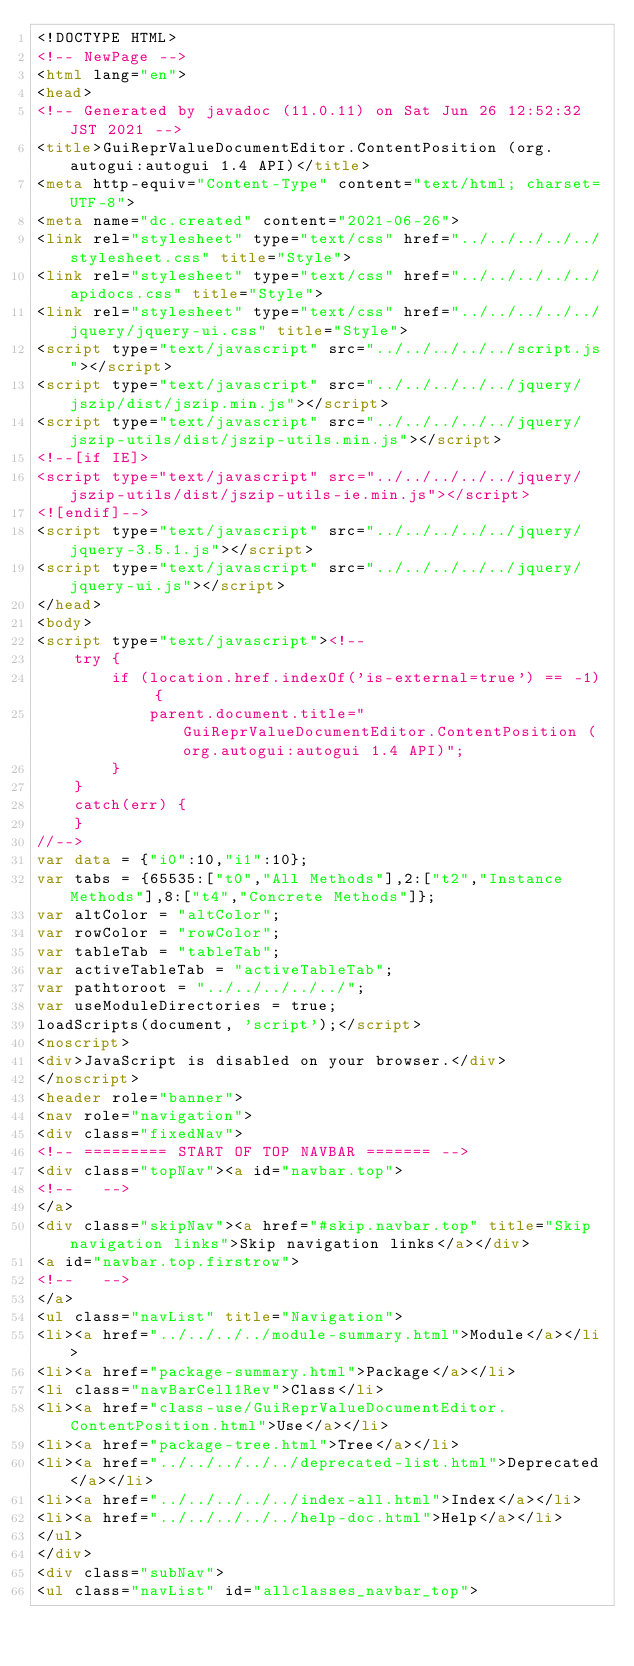Convert code to text. <code><loc_0><loc_0><loc_500><loc_500><_HTML_><!DOCTYPE HTML>
<!-- NewPage -->
<html lang="en">
<head>
<!-- Generated by javadoc (11.0.11) on Sat Jun 26 12:52:32 JST 2021 -->
<title>GuiReprValueDocumentEditor.ContentPosition (org.autogui:autogui 1.4 API)</title>
<meta http-equiv="Content-Type" content="text/html; charset=UTF-8">
<meta name="dc.created" content="2021-06-26">
<link rel="stylesheet" type="text/css" href="../../../../../stylesheet.css" title="Style">
<link rel="stylesheet" type="text/css" href="../../../../../apidocs.css" title="Style">
<link rel="stylesheet" type="text/css" href="../../../../../jquery/jquery-ui.css" title="Style">
<script type="text/javascript" src="../../../../../script.js"></script>
<script type="text/javascript" src="../../../../../jquery/jszip/dist/jszip.min.js"></script>
<script type="text/javascript" src="../../../../../jquery/jszip-utils/dist/jszip-utils.min.js"></script>
<!--[if IE]>
<script type="text/javascript" src="../../../../../jquery/jszip-utils/dist/jszip-utils-ie.min.js"></script>
<![endif]-->
<script type="text/javascript" src="../../../../../jquery/jquery-3.5.1.js"></script>
<script type="text/javascript" src="../../../../../jquery/jquery-ui.js"></script>
</head>
<body>
<script type="text/javascript"><!--
    try {
        if (location.href.indexOf('is-external=true') == -1) {
            parent.document.title="GuiReprValueDocumentEditor.ContentPosition (org.autogui:autogui 1.4 API)";
        }
    }
    catch(err) {
    }
//-->
var data = {"i0":10,"i1":10};
var tabs = {65535:["t0","All Methods"],2:["t2","Instance Methods"],8:["t4","Concrete Methods"]};
var altColor = "altColor";
var rowColor = "rowColor";
var tableTab = "tableTab";
var activeTableTab = "activeTableTab";
var pathtoroot = "../../../../../";
var useModuleDirectories = true;
loadScripts(document, 'script');</script>
<noscript>
<div>JavaScript is disabled on your browser.</div>
</noscript>
<header role="banner">
<nav role="navigation">
<div class="fixedNav">
<!-- ========= START OF TOP NAVBAR ======= -->
<div class="topNav"><a id="navbar.top">
<!--   -->
</a>
<div class="skipNav"><a href="#skip.navbar.top" title="Skip navigation links">Skip navigation links</a></div>
<a id="navbar.top.firstrow">
<!--   -->
</a>
<ul class="navList" title="Navigation">
<li><a href="../../../../module-summary.html">Module</a></li>
<li><a href="package-summary.html">Package</a></li>
<li class="navBarCell1Rev">Class</li>
<li><a href="class-use/GuiReprValueDocumentEditor.ContentPosition.html">Use</a></li>
<li><a href="package-tree.html">Tree</a></li>
<li><a href="../../../../../deprecated-list.html">Deprecated</a></li>
<li><a href="../../../../../index-all.html">Index</a></li>
<li><a href="../../../../../help-doc.html">Help</a></li>
</ul>
</div>
<div class="subNav">
<ul class="navList" id="allclasses_navbar_top"></code> 